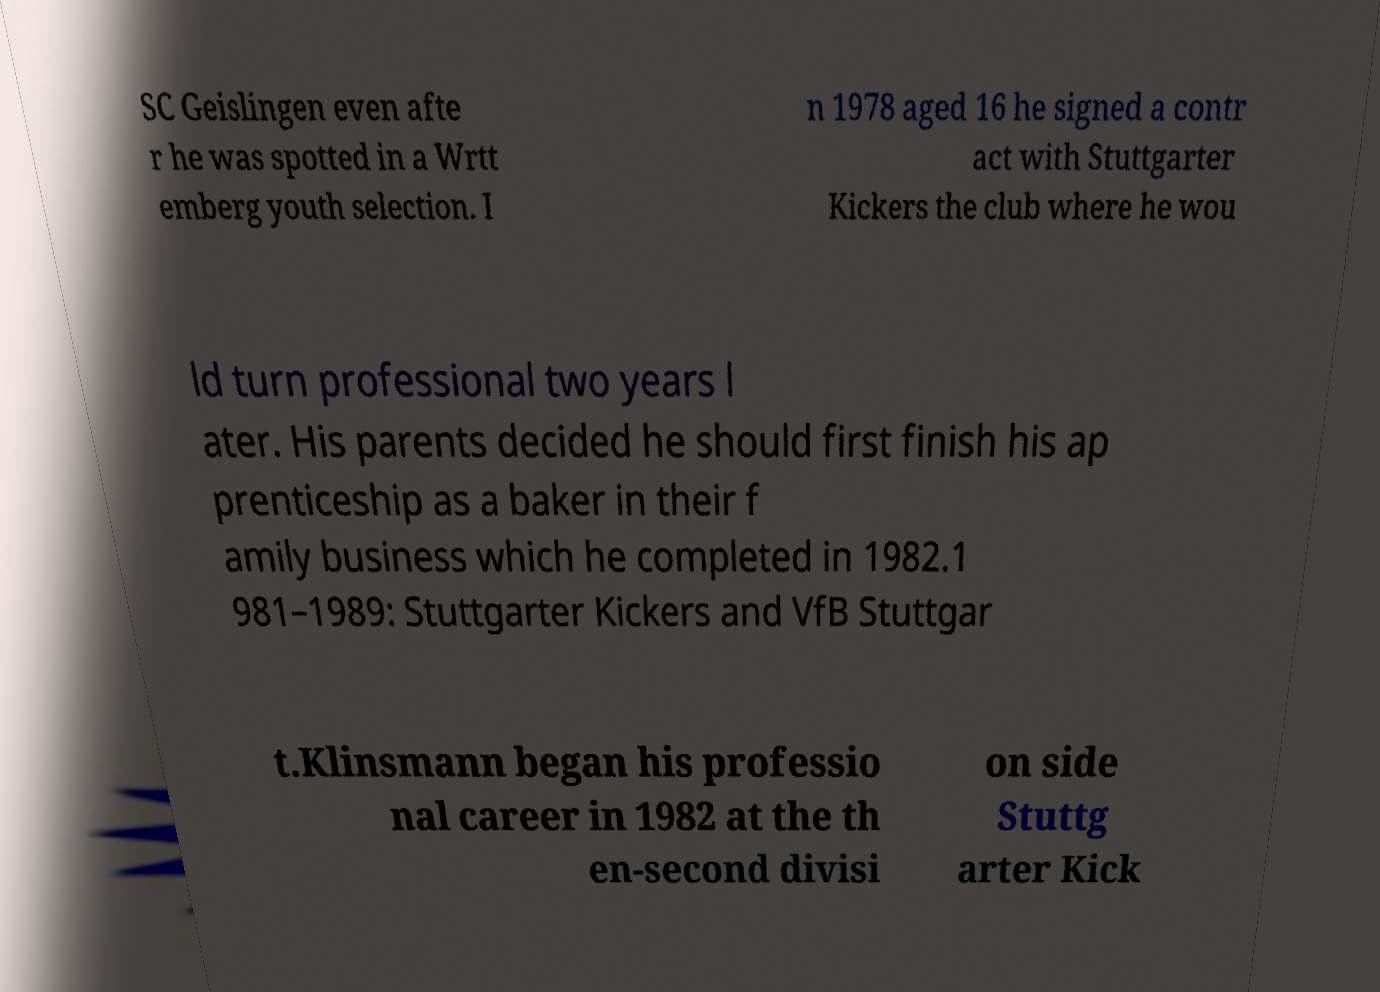Could you assist in decoding the text presented in this image and type it out clearly? SC Geislingen even afte r he was spotted in a Wrtt emberg youth selection. I n 1978 aged 16 he signed a contr act with Stuttgarter Kickers the club where he wou ld turn professional two years l ater. His parents decided he should first finish his ap prenticeship as a baker in their f amily business which he completed in 1982.1 981–1989: Stuttgarter Kickers and VfB Stuttgar t.Klinsmann began his professio nal career in 1982 at the th en-second divisi on side Stuttg arter Kick 